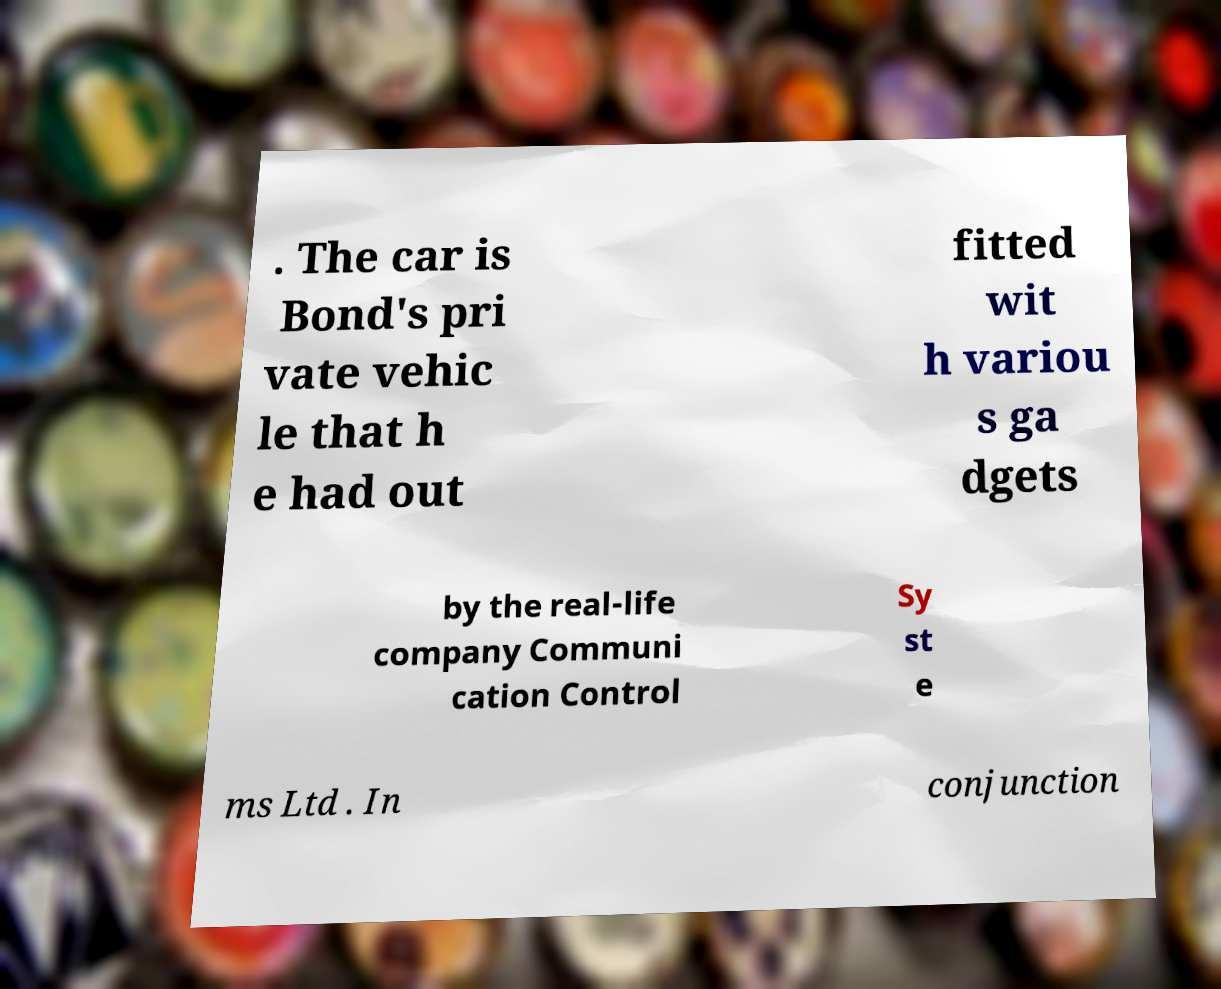Could you assist in decoding the text presented in this image and type it out clearly? . The car is Bond's pri vate vehic le that h e had out fitted wit h variou s ga dgets by the real-life company Communi cation Control Sy st e ms Ltd . In conjunction 